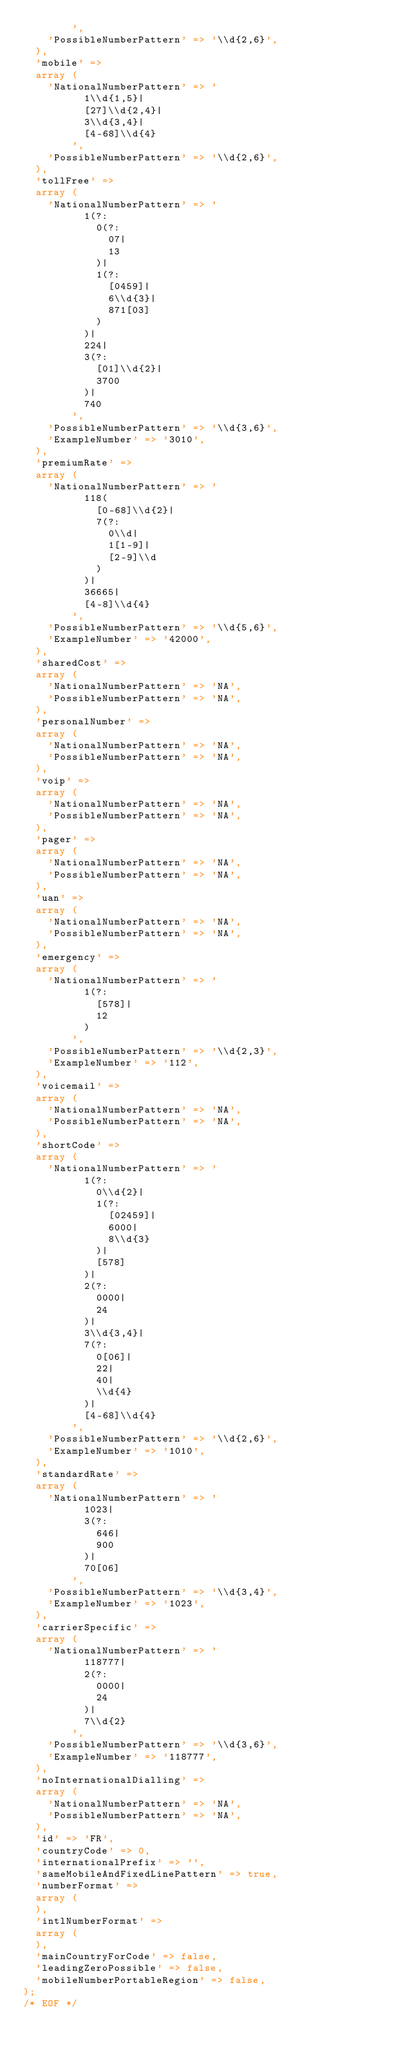Convert code to text. <code><loc_0><loc_0><loc_500><loc_500><_PHP_>        ',
    'PossibleNumberPattern' => '\\d{2,6}',
  ),
  'mobile' => 
  array (
    'NationalNumberPattern' => '
          1\\d{1,5}|
          [27]\\d{2,4}|
          3\\d{3,4}|
          [4-68]\\d{4}
        ',
    'PossibleNumberPattern' => '\\d{2,6}',
  ),
  'tollFree' => 
  array (
    'NationalNumberPattern' => '
          1(?:
            0(?:
              07|
              13
            )|
            1(?:
              [0459]|
              6\\d{3}|
              871[03]
            )
          )|
          224|
          3(?:
            [01]\\d{2}|
            3700
          )|
          740
        ',
    'PossibleNumberPattern' => '\\d{3,6}',
    'ExampleNumber' => '3010',
  ),
  'premiumRate' => 
  array (
    'NationalNumberPattern' => '
          118(
            [0-68]\\d{2}|
            7(?:
              0\\d|
              1[1-9]|
              [2-9]\\d
            )
          )|
          36665|
          [4-8]\\d{4}
        ',
    'PossibleNumberPattern' => '\\d{5,6}',
    'ExampleNumber' => '42000',
  ),
  'sharedCost' => 
  array (
    'NationalNumberPattern' => 'NA',
    'PossibleNumberPattern' => 'NA',
  ),
  'personalNumber' => 
  array (
    'NationalNumberPattern' => 'NA',
    'PossibleNumberPattern' => 'NA',
  ),
  'voip' => 
  array (
    'NationalNumberPattern' => 'NA',
    'PossibleNumberPattern' => 'NA',
  ),
  'pager' => 
  array (
    'NationalNumberPattern' => 'NA',
    'PossibleNumberPattern' => 'NA',
  ),
  'uan' => 
  array (
    'NationalNumberPattern' => 'NA',
    'PossibleNumberPattern' => 'NA',
  ),
  'emergency' => 
  array (
    'NationalNumberPattern' => '
          1(?:
            [578]|
            12
          )
        ',
    'PossibleNumberPattern' => '\\d{2,3}',
    'ExampleNumber' => '112',
  ),
  'voicemail' => 
  array (
    'NationalNumberPattern' => 'NA',
    'PossibleNumberPattern' => 'NA',
  ),
  'shortCode' => 
  array (
    'NationalNumberPattern' => '
          1(?:
            0\\d{2}|
            1(?:
              [02459]|
              6000|
              8\\d{3}
            )|
            [578]
          )|
          2(?:
            0000|
            24
          )|
          3\\d{3,4}|
          7(?:
            0[06]|
            22|
            40|
            \\d{4}
          )|
          [4-68]\\d{4}
        ',
    'PossibleNumberPattern' => '\\d{2,6}',
    'ExampleNumber' => '1010',
  ),
  'standardRate' => 
  array (
    'NationalNumberPattern' => '
          1023|
          3(?:
            646|
            900
          )|
          70[06]
        ',
    'PossibleNumberPattern' => '\\d{3,4}',
    'ExampleNumber' => '1023',
  ),
  'carrierSpecific' => 
  array (
    'NationalNumberPattern' => '
          118777|
          2(?:
            0000|
            24
          )|
          7\\d{2}
        ',
    'PossibleNumberPattern' => '\\d{3,6}',
    'ExampleNumber' => '118777',
  ),
  'noInternationalDialling' => 
  array (
    'NationalNumberPattern' => 'NA',
    'PossibleNumberPattern' => 'NA',
  ),
  'id' => 'FR',
  'countryCode' => 0,
  'internationalPrefix' => '',
  'sameMobileAndFixedLinePattern' => true,
  'numberFormat' => 
  array (
  ),
  'intlNumberFormat' => 
  array (
  ),
  'mainCountryForCode' => false,
  'leadingZeroPossible' => false,
  'mobileNumberPortableRegion' => false,
);
/* EOF */</code> 